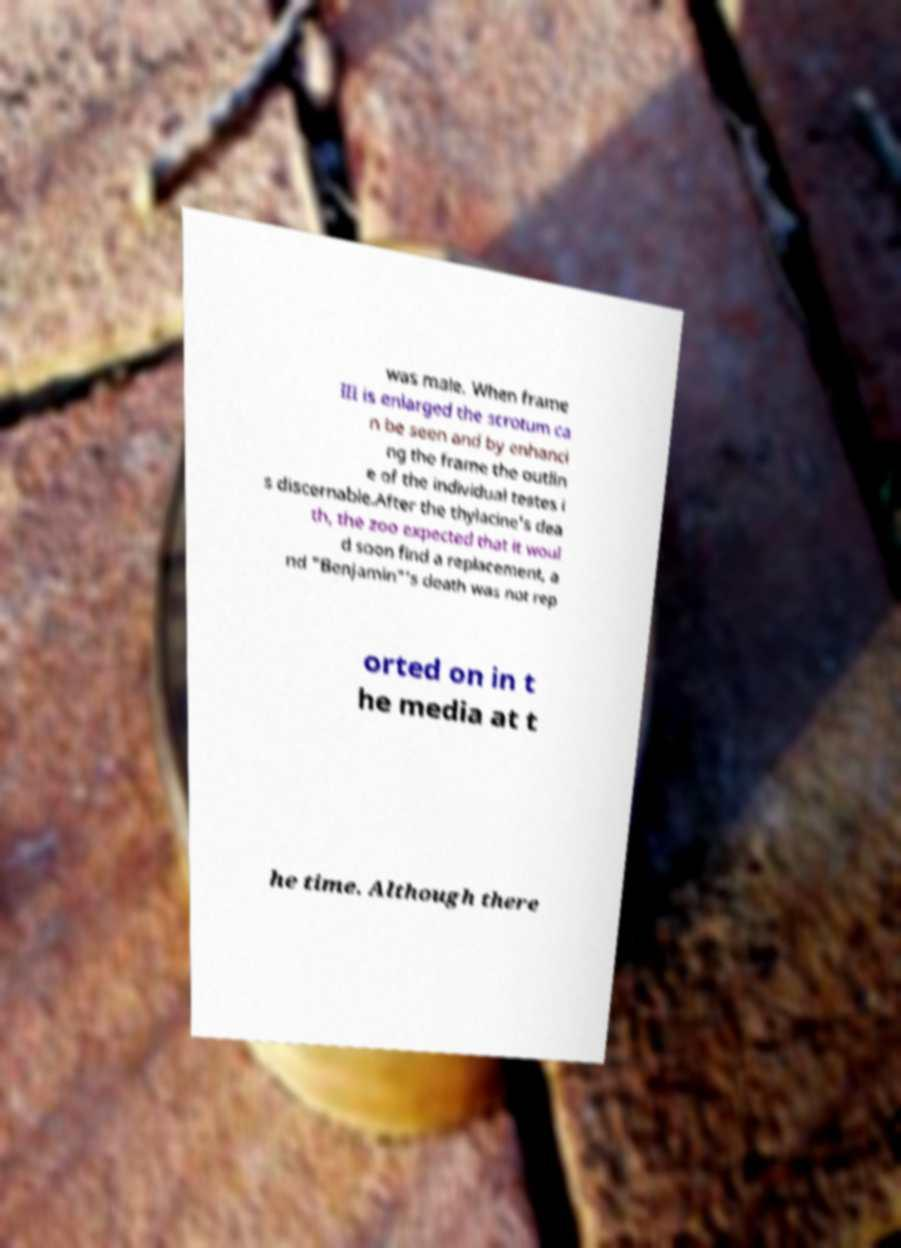Can you accurately transcribe the text from the provided image for me? was male. When frame III is enlarged the scrotum ca n be seen and by enhanci ng the frame the outlin e of the individual testes i s discernable.After the thylacine's dea th, the zoo expected that it woul d soon find a replacement, a nd "Benjamin"'s death was not rep orted on in t he media at t he time. Although there 